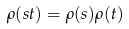Convert formula to latex. <formula><loc_0><loc_0><loc_500><loc_500>\rho ( s t ) = \rho ( s ) \rho ( t )</formula> 